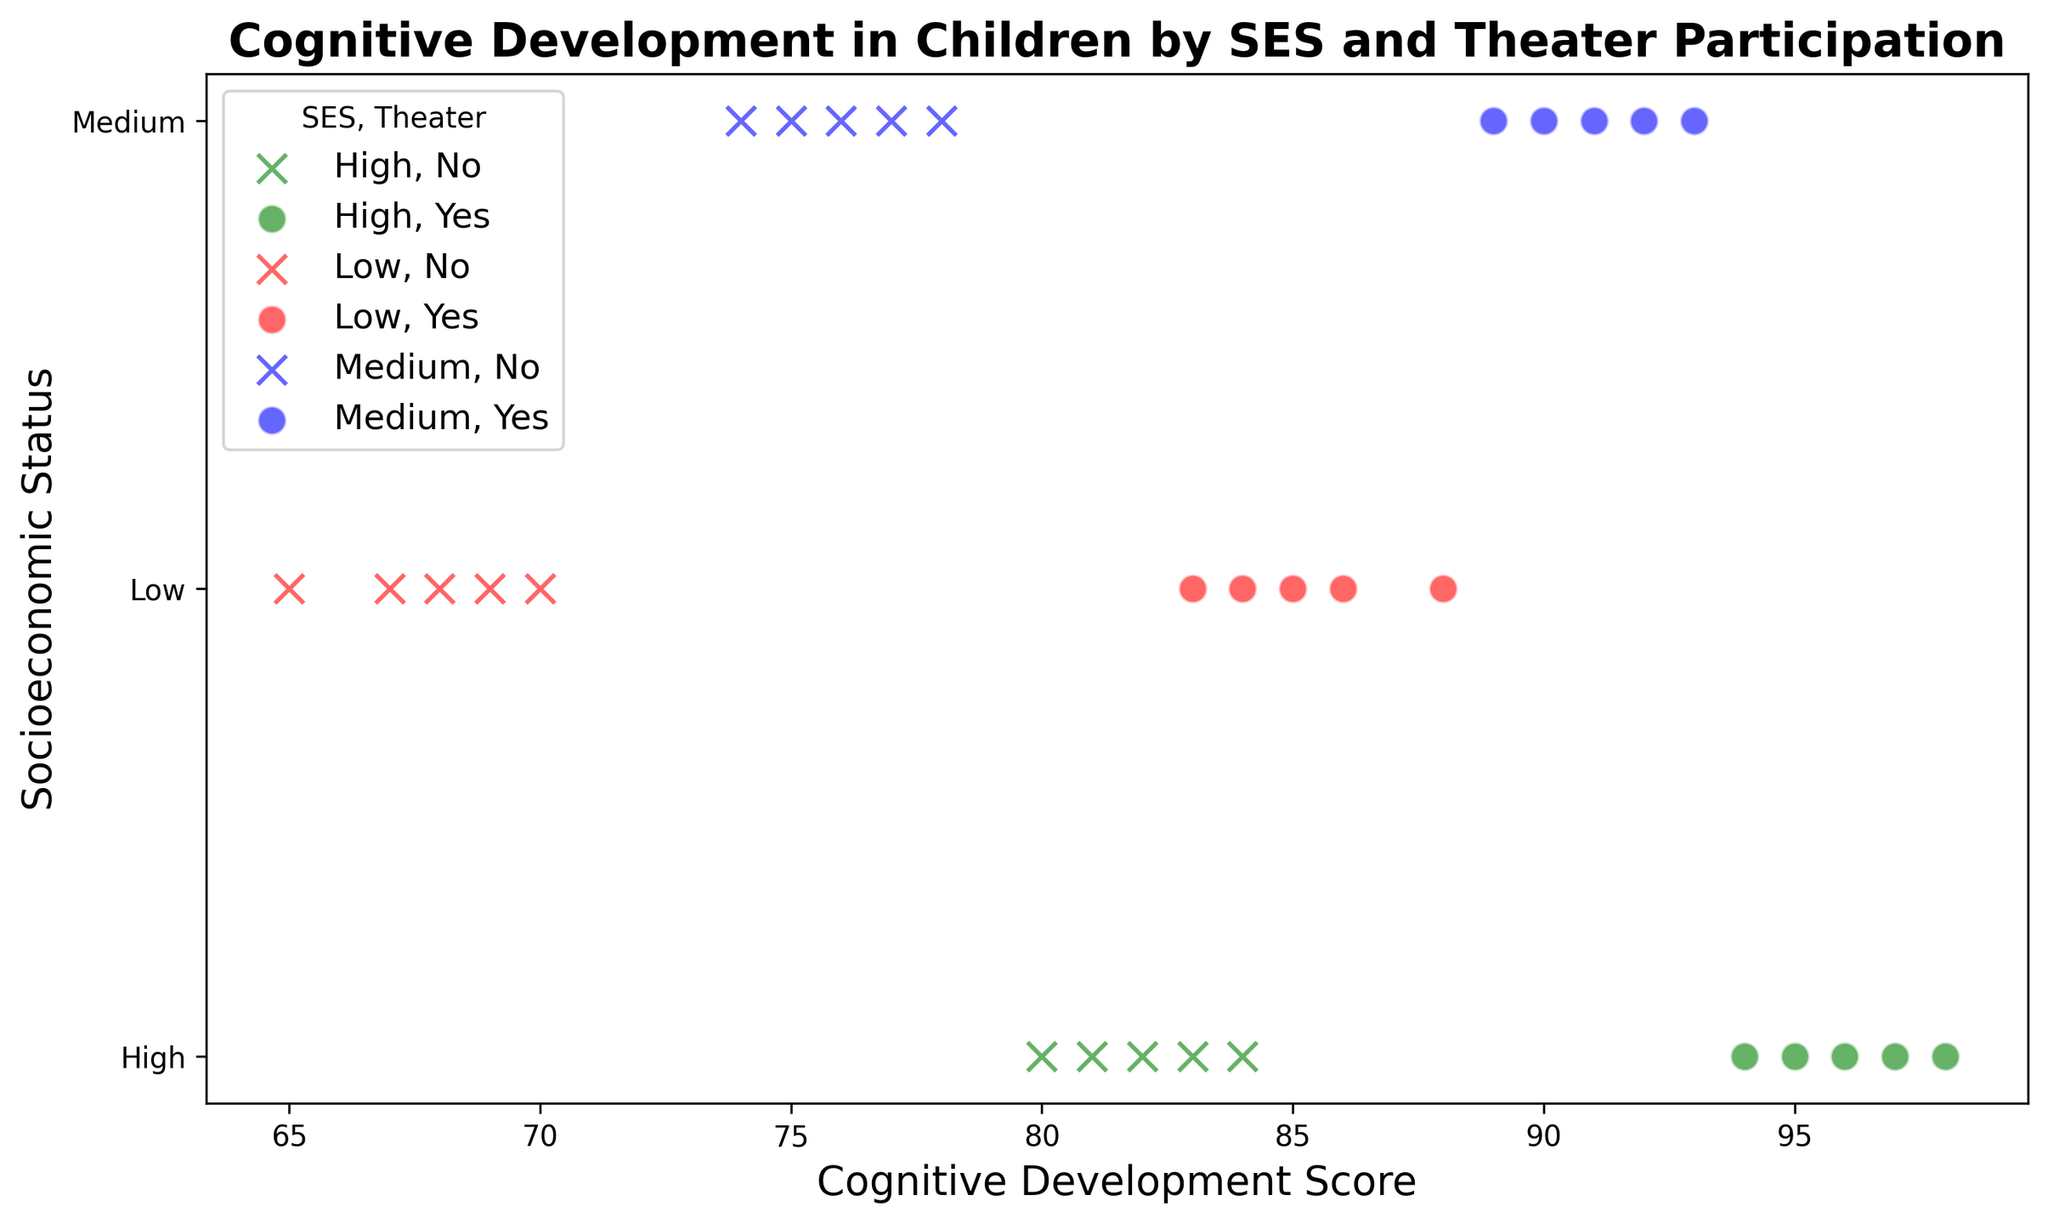What trend do you observe in the cognitive development scores between children who participate in theater and those who don't? Upon inspecting the scatter plot, children who participate in theater (marked with circles) generally have higher cognitive development scores across all socioeconomic status (SES) levels as compared to those who don't participate in theater (marked with x's).
Answer: Children participating in theater have higher cognitive scores Which group has the highest cognitive development score? In the scatter plot, children from high SES who participate in theater (green markers) have the highest cognitive development scores. The maximum score is 98.
Answer: High SES children in theater Among children from low SES, what is the difference in average cognitive development scores between those who participate in theater and those who don't? First, sum the cognitive scores for low SES in theater (85, 88, 84, 86, 83) and those not in theater (70, 65, 68, 67, 69). Calculate the averages: (85+88+84+86+83)/5 = 85.2 and (70+65+68+67+69)/5 = 67.8. The difference is 85.2 - 67.8.
Answer: 17.4 points In the medium SES group, is there a substantial difference in the distribution of cognitive development scores between children who participate in theater and those who don't? Inspecting the plot, children from medium SES who participate in theater (blue circles) have cognitive scores ranging from 89 to 93, while those who don't (blue x's) range from 74 to 78. The theater group generally has higher scores, indicating a substantial difference.
Answer: Yes, substantial difference How does socioeconomic status (SES) influence the cognitive development score for children involved in theater? Observing the scatter plot, children involved in theater show an increasing trend in cognitive development scores from low (red circles), to medium (blue circles), to high (green circles) SES. The higher the SES, the higher the cognitive development score.
Answer: Higher SES corresponds to higher scores What is the combined average cognitive development score for children in medium SES irrespective of theater participation? Compute the average for all medium SES scores: (90, 75, 92, 78, 91, 76, 93, 77, 89, 74). Sum these scores: 90+75+92+78+91+76+93+77+89+74 = 835. Divide by the number of data points, 10.
Answer: 83.5 Between children from the same SES group, who has larger variability in cognitive development scores - those involved in theater or those who are not? For each SES group, compare the range (max-min) of cognitive development scores. Low SES theater: (88-83), non-theater: (70-65); Medium SES theater: (93-89), non-theater: (78-74); High SES theater: (98-94), non-theater: (84-80). Children not involved in theater generally exhibit a smaller range.
Answer: Theater participants have larger variability What is the lowest cognitive development score among children involved in theater from all SES groups? Observing the scatter plot, the lowest score among children involved in theater (circles) appears to be in the low SES group, which is 83.
Answer: 83 Is there a notable difference in cognitive development scores between children from high SES who don't participate in theater and those from low SES who do? Comparing high SES non-theater (80, 82, 81, 83, 84) with low SES theater (85, 88, 84, 86, 83), the high SES group without theater generally has slightly lower scores than the low SES group with theater.
Answer: Low SES theater scores higher Do children from high SES who do not participate in theater outperform children from medium SES who do participate in theater on average? Calculate the averages for high SES non-theater (80, 82, 81, 83, 84): (80+82+81+83+84)/5 = 82. Compute the medium SES theater (90, 92, 91, 93, 89): (90+92+91+93+89)/5 = 91. Medium SES theater participants have higher average scores.
Answer: No, medium SES theater scores higher 